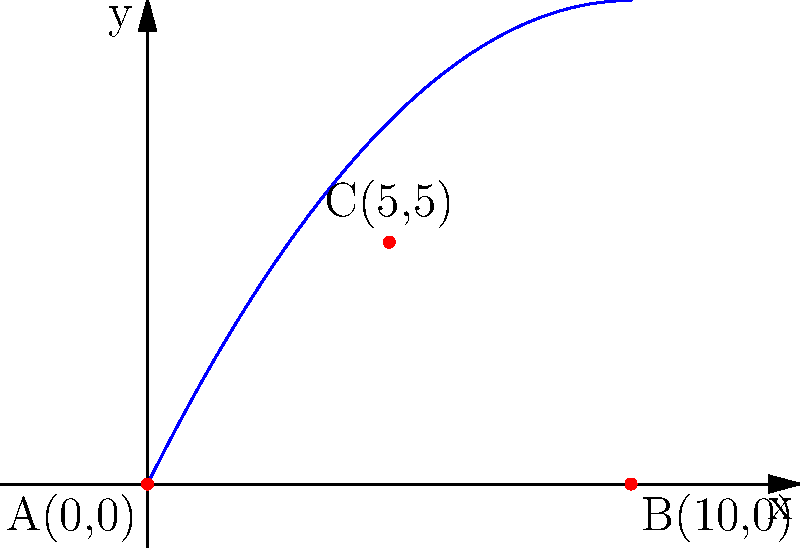As a soccer player, you're practicing your kicks and analyzing the ball's trajectory. The path of the ball can be modeled by the quadratic function $f(x) = -0.1x^2 + 2x$, where $x$ represents the horizontal distance and $f(x)$ represents the height, both measured in meters. The ball starts at point A(0,0), reaches its maximum height at point C, and lands at point B. What are the coordinates of point C, the highest point of the ball's trajectory? To find the coordinates of point C, we need to follow these steps:

1) The x-coordinate of the highest point occurs at the axis of symmetry of the parabola. For a quadratic function in the form $f(x) = ax^2 + bx + c$, the x-coordinate of the vertex is given by $x = -\frac{b}{2a}$.

2) In our function $f(x) = -0.1x^2 + 2x$, we have $a = -0.1$ and $b = 2$.

3) Substituting these values:
   $x = -\frac{2}{2(-0.1)} = -\frac{2}{-0.2} = 10 \div 2 = 5$

4) So the x-coordinate of point C is 5.

5) To find the y-coordinate, we substitute x = 5 into the original function:
   $f(5) = -0.1(5)^2 + 2(5)$
   $    = -0.1(25) + 10$
   $    = -2.5 + 10 = 5$

6) Therefore, the y-coordinate of point C is also 5.
Answer: C(5,5) 